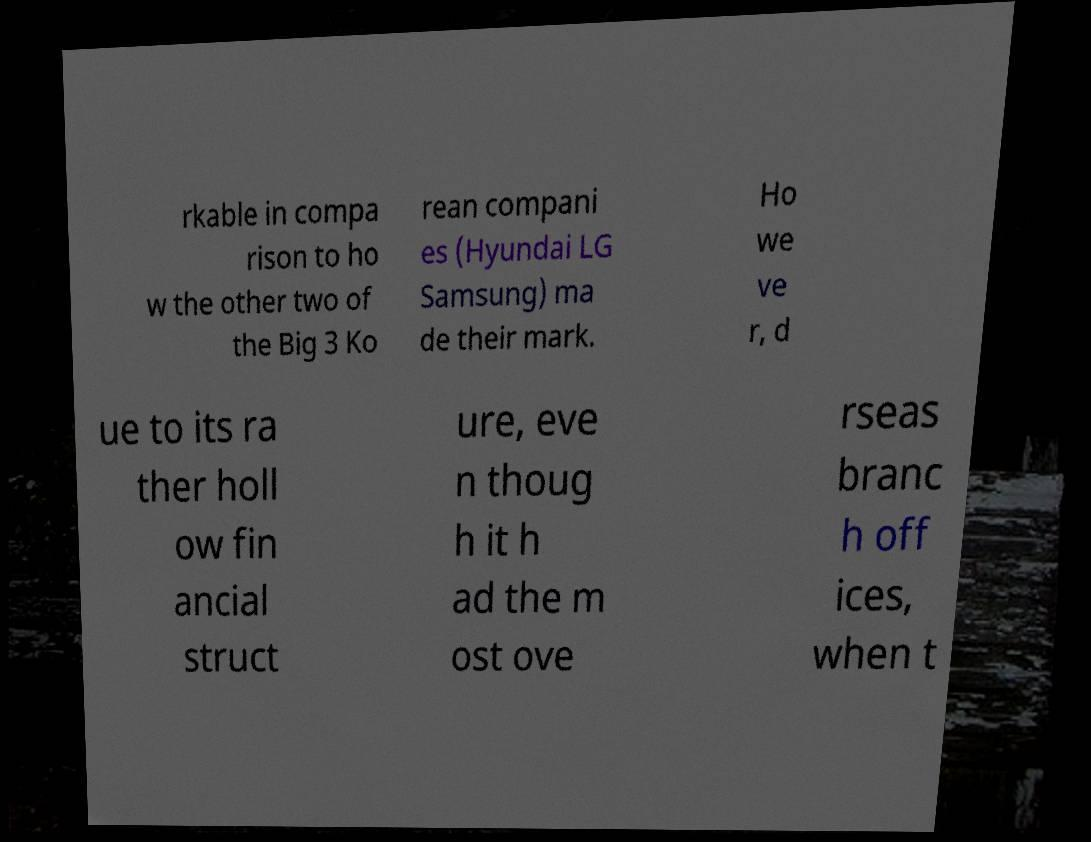Can you read and provide the text displayed in the image?This photo seems to have some interesting text. Can you extract and type it out for me? rkable in compa rison to ho w the other two of the Big 3 Ko rean compani es (Hyundai LG Samsung) ma de their mark. Ho we ve r, d ue to its ra ther holl ow fin ancial struct ure, eve n thoug h it h ad the m ost ove rseas branc h off ices, when t 